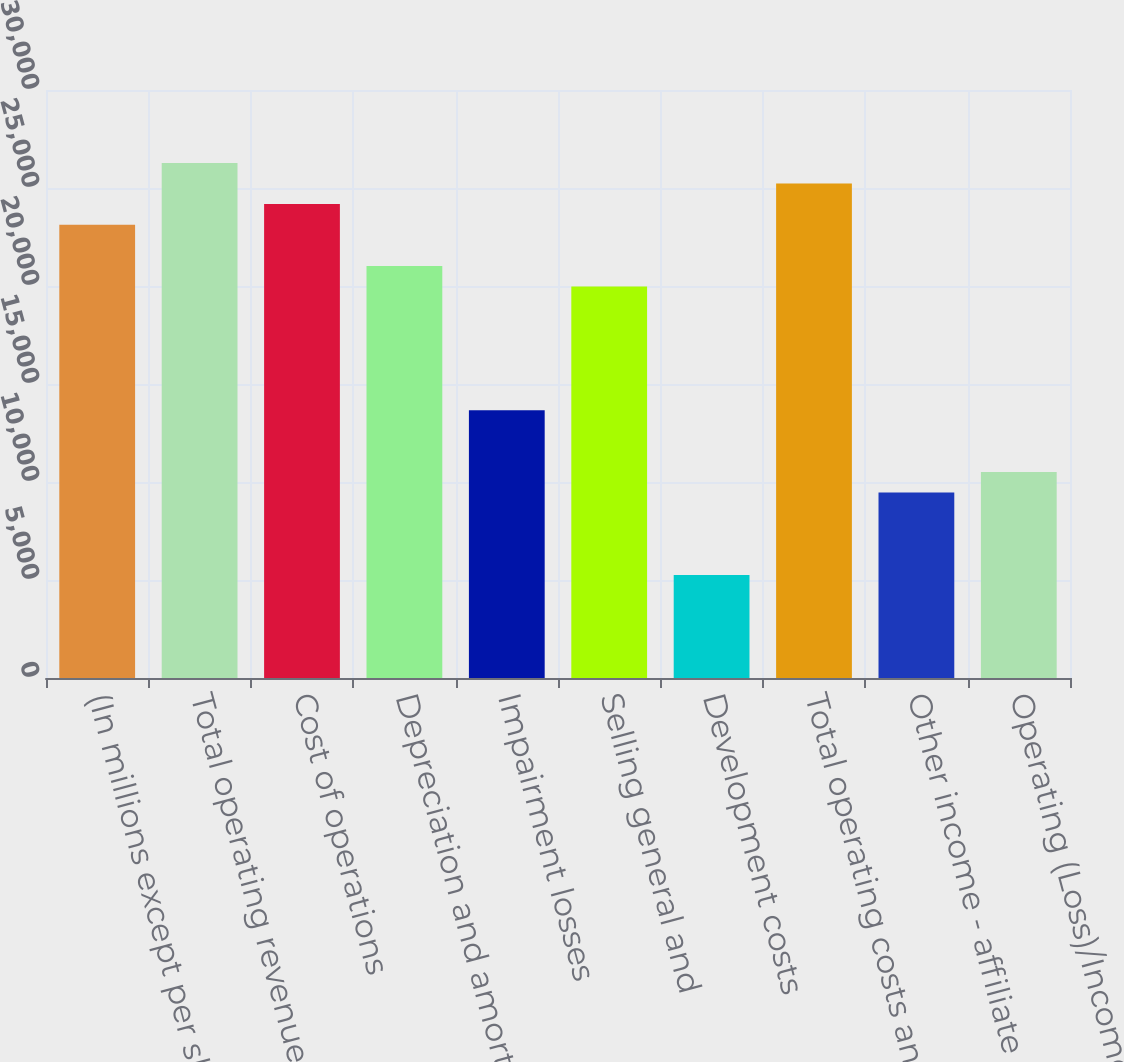Convert chart. <chart><loc_0><loc_0><loc_500><loc_500><bar_chart><fcel>(In millions except per share<fcel>Total operating revenues<fcel>Cost of operations<fcel>Depreciation and amortization<fcel>Impairment losses<fcel>Selling general and<fcel>Development costs<fcel>Total operating costs and<fcel>Other income - affiliate<fcel>Operating (Loss)/Income<nl><fcel>23126.2<fcel>26279.7<fcel>24177.4<fcel>21023.8<fcel>13665.6<fcel>19972.7<fcel>5256.14<fcel>25228.6<fcel>9460.86<fcel>10512<nl></chart> 